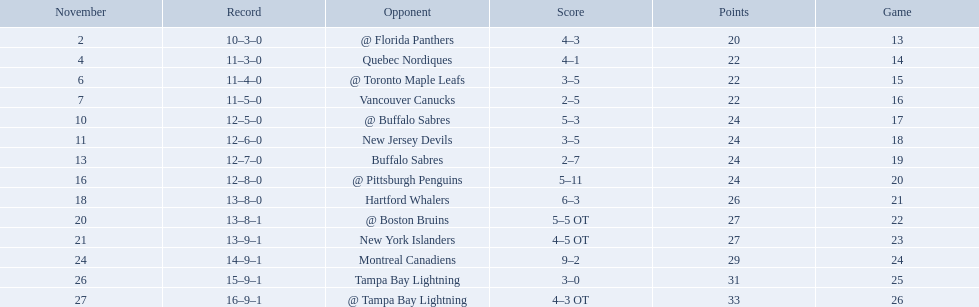What were the scores of the 1993-94 philadelphia flyers season? 4–3, 4–1, 3–5, 2–5, 5–3, 3–5, 2–7, 5–11, 6–3, 5–5 OT, 4–5 OT, 9–2, 3–0, 4–3 OT. Which of these teams had the score 4-5 ot? New York Islanders. 